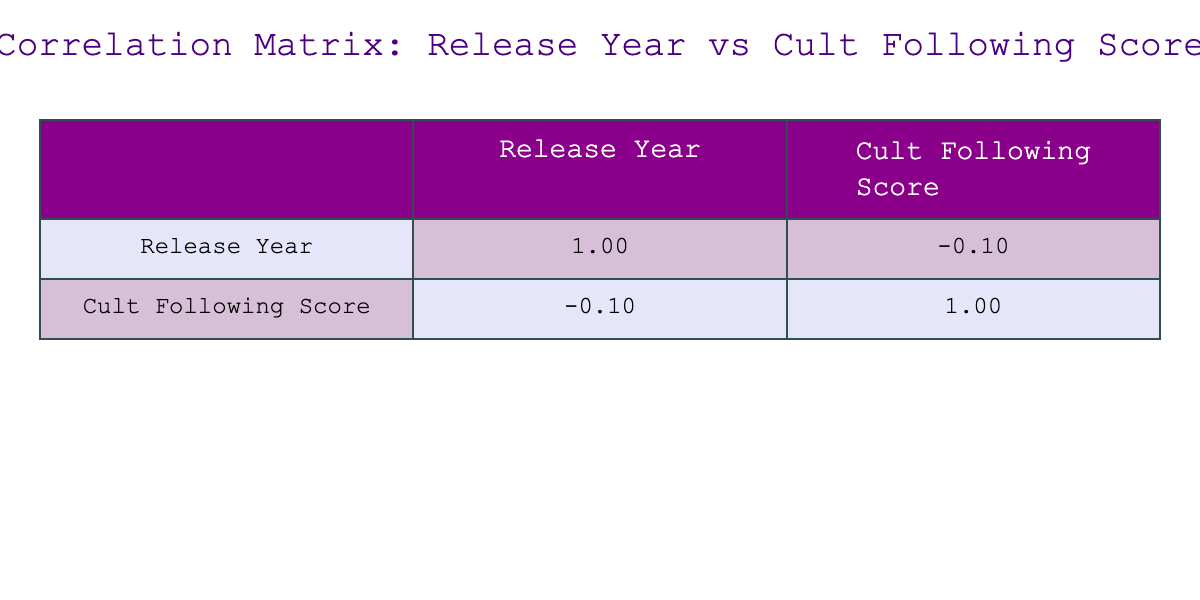What is the correlation coefficient between Release Year and Cult Following Score? The correlation matrix shows two values: the correlation between Release Year and itself is 1.00, which is a basic statistical property. The value of interest is the correlation between Release Year and Cult Following Score, which is -0.31. This indicates a slight negative correlation.
Answer: -0.31 Which film released in 2003 has the highest Cult Following Score? According to the table, "The Room" is the only film from 2003 listed, and it has a Cult Following Score of 95.
Answer: "The Room" Is there a film released in the 1980s that has a Cult Following Score above 80? The table lists "Brazil" (1985) with a score of 82 and "Labyrinth" (1986) with a score of 83. Both scores exceed 80.
Answer: Yes What is the average Cult Following Score of films released before the year 2000? The films before 2000 are: "Brazil" (82), "Rocky Horror Picture Show" (98), "Eraserhead" (75), "Clerks" (70), "Harold and Maude" (87), "Pink Flamingos" (76), "Withnail and I" (79), "Labyrinth" (83), and "Suspiria" (88). The sum of their scores is 80.78, calculated as follows: (82 + 98 + 75 + 70 + 87 + 76 + 79 + 83 + 88) = 818, divided by the number of films, which is 9. Thus, the average is 818/9 ≈ 90.89.
Answer: 90.89 Which film scored lowest in the Cult Following Score and what was the year of its release? The film with the lowest Cult Following Score is "Battlefield Earth" (2000), which scored 60.
Answer: "Battlefield Earth", 2000 What is the difference in Cult Following Scores between "Rocky Horror Picture Show" and "Donnie Darko"? "Rocky Horror Picture Show" has a score of 98 while "Donnie Darko" has a score of 88. The difference can be calculated as 98 - 88 = 10.
Answer: 10 Is "Donnie Darko" the only Sci-Fi film with a Cult Following Score above 85? The table features two Sci-Fi films: "Donnie Darko" with a score of 88 and "Battlefield Earth" with a score of 60. Since "Battlefield Earth" does not exceed 85, it confirms that "Donnie Darko" is indeed the only one that meets the criteria.
Answer: Yes 